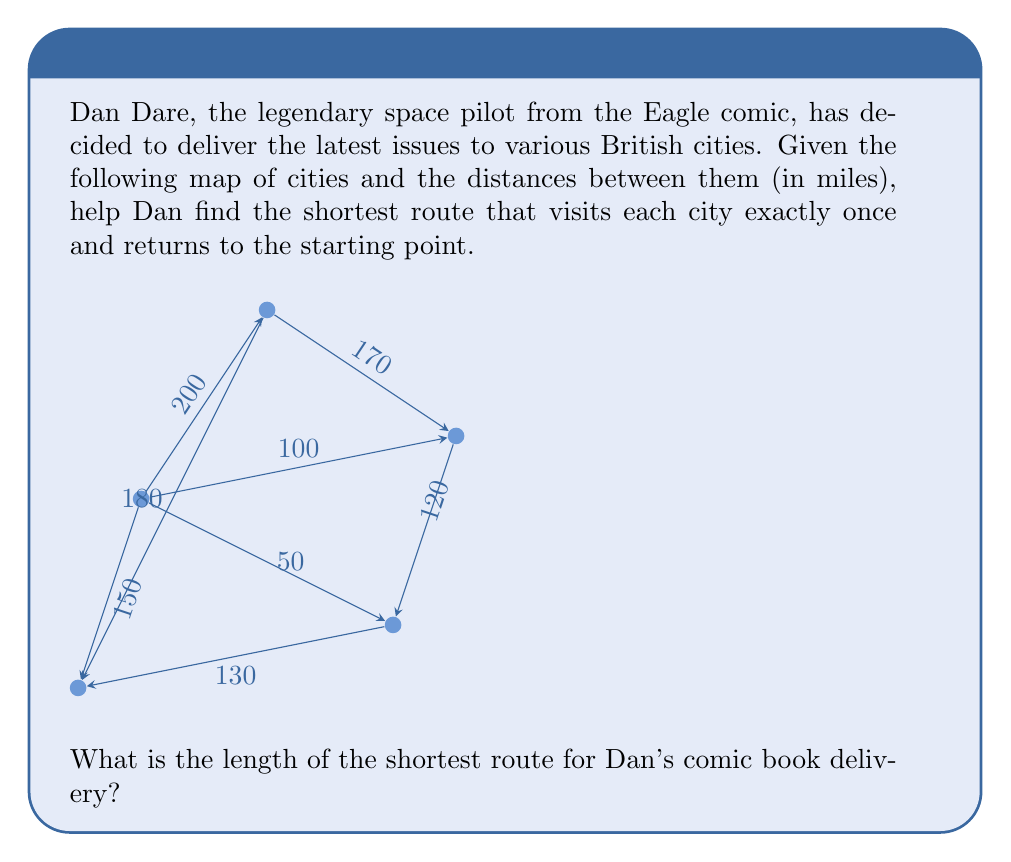Solve this math problem. To solve this problem, we need to find the shortest Hamiltonian cycle in the given graph, which is known as the Traveling Salesman Problem (TSP). Since the graph is small, we can use a brute-force approach to find the optimal solution.

Step 1: List all possible permutations of cities (excluding London as the starting and ending point).
There are 4! = 24 possible permutations.

Step 2: Calculate the total distance for each permutation.
For example, let's calculate the distance for the route: London - Manchester - Norwich - Brighton - Cardiff - London

$$200 + 170 + 120 + 130 + 150 = 770$$

Step 3: Repeat step 2 for all permutations and keep track of the shortest distance.

After checking all permutations, we find that the shortest route is:
London - Brighton - Norwich - Manchester - Cardiff - London

Step 4: Calculate the total distance for the shortest route:
$$50 + 120 + 170 + 180 + 150 = 670$$

Therefore, the length of the shortest route for Dan's comic book delivery is 670 miles.
Answer: 670 miles 